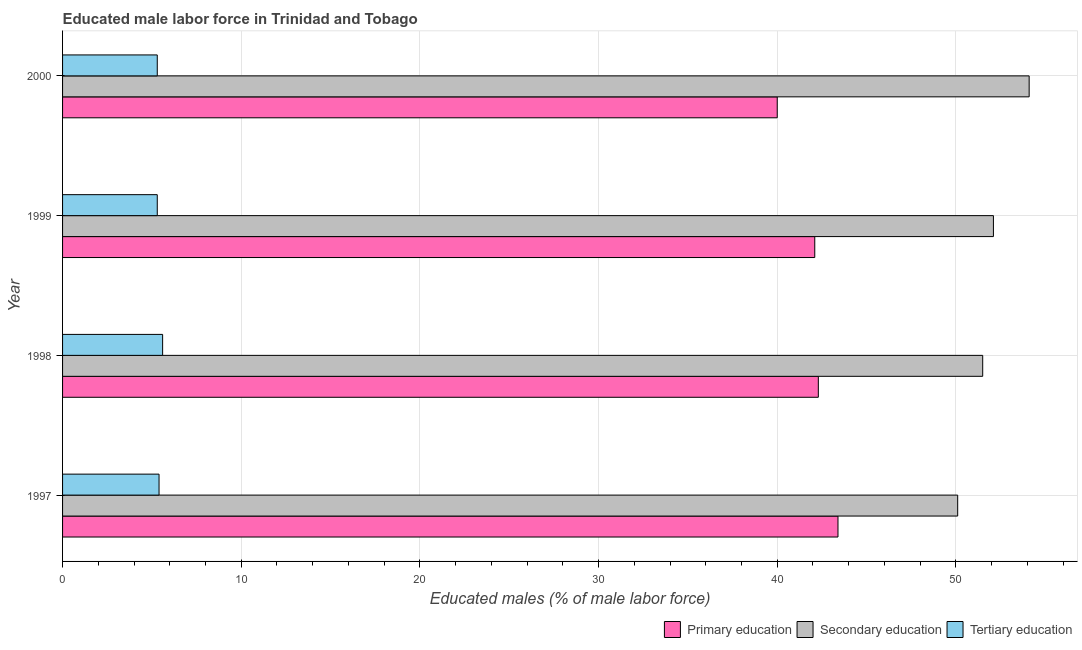How many groups of bars are there?
Offer a terse response. 4. How many bars are there on the 1st tick from the top?
Your response must be concise. 3. In how many cases, is the number of bars for a given year not equal to the number of legend labels?
Give a very brief answer. 0. What is the percentage of male labor force who received tertiary education in 2000?
Provide a succinct answer. 5.3. Across all years, what is the maximum percentage of male labor force who received secondary education?
Offer a very short reply. 54.1. Across all years, what is the minimum percentage of male labor force who received tertiary education?
Offer a terse response. 5.3. In which year was the percentage of male labor force who received primary education minimum?
Provide a succinct answer. 2000. What is the total percentage of male labor force who received secondary education in the graph?
Provide a short and direct response. 207.8. What is the difference between the percentage of male labor force who received primary education in 1999 and that in 2000?
Your response must be concise. 2.1. What is the difference between the percentage of male labor force who received tertiary education in 1997 and the percentage of male labor force who received secondary education in 1998?
Keep it short and to the point. -46.1. What is the average percentage of male labor force who received secondary education per year?
Offer a very short reply. 51.95. In the year 2000, what is the difference between the percentage of male labor force who received primary education and percentage of male labor force who received tertiary education?
Give a very brief answer. 34.7. In how many years, is the percentage of male labor force who received tertiary education greater than 38 %?
Provide a short and direct response. 0. What is the ratio of the percentage of male labor force who received primary education in 1998 to that in 2000?
Give a very brief answer. 1.06. Is the difference between the percentage of male labor force who received tertiary education in 1997 and 1999 greater than the difference between the percentage of male labor force who received secondary education in 1997 and 1999?
Make the answer very short. Yes. Is the sum of the percentage of male labor force who received tertiary education in 1998 and 1999 greater than the maximum percentage of male labor force who received primary education across all years?
Your answer should be compact. No. Is it the case that in every year, the sum of the percentage of male labor force who received primary education and percentage of male labor force who received secondary education is greater than the percentage of male labor force who received tertiary education?
Provide a short and direct response. Yes. How many bars are there?
Ensure brevity in your answer.  12. Are all the bars in the graph horizontal?
Your response must be concise. Yes. Are the values on the major ticks of X-axis written in scientific E-notation?
Make the answer very short. No. Does the graph contain any zero values?
Your answer should be very brief. No. Does the graph contain grids?
Your response must be concise. Yes. Where does the legend appear in the graph?
Your answer should be very brief. Bottom right. How are the legend labels stacked?
Provide a succinct answer. Horizontal. What is the title of the graph?
Give a very brief answer. Educated male labor force in Trinidad and Tobago. Does "Labor Market" appear as one of the legend labels in the graph?
Keep it short and to the point. No. What is the label or title of the X-axis?
Offer a terse response. Educated males (% of male labor force). What is the label or title of the Y-axis?
Give a very brief answer. Year. What is the Educated males (% of male labor force) of Primary education in 1997?
Your answer should be compact. 43.4. What is the Educated males (% of male labor force) in Secondary education in 1997?
Provide a succinct answer. 50.1. What is the Educated males (% of male labor force) in Tertiary education in 1997?
Your response must be concise. 5.4. What is the Educated males (% of male labor force) of Primary education in 1998?
Provide a succinct answer. 42.3. What is the Educated males (% of male labor force) of Secondary education in 1998?
Give a very brief answer. 51.5. What is the Educated males (% of male labor force) of Tertiary education in 1998?
Offer a very short reply. 5.6. What is the Educated males (% of male labor force) in Primary education in 1999?
Make the answer very short. 42.1. What is the Educated males (% of male labor force) of Secondary education in 1999?
Your answer should be very brief. 52.1. What is the Educated males (% of male labor force) in Tertiary education in 1999?
Give a very brief answer. 5.3. What is the Educated males (% of male labor force) in Primary education in 2000?
Provide a succinct answer. 40. What is the Educated males (% of male labor force) of Secondary education in 2000?
Offer a terse response. 54.1. What is the Educated males (% of male labor force) of Tertiary education in 2000?
Keep it short and to the point. 5.3. Across all years, what is the maximum Educated males (% of male labor force) of Primary education?
Keep it short and to the point. 43.4. Across all years, what is the maximum Educated males (% of male labor force) in Secondary education?
Provide a short and direct response. 54.1. Across all years, what is the maximum Educated males (% of male labor force) of Tertiary education?
Keep it short and to the point. 5.6. Across all years, what is the minimum Educated males (% of male labor force) in Secondary education?
Your answer should be very brief. 50.1. Across all years, what is the minimum Educated males (% of male labor force) of Tertiary education?
Your answer should be very brief. 5.3. What is the total Educated males (% of male labor force) in Primary education in the graph?
Your answer should be compact. 167.8. What is the total Educated males (% of male labor force) of Secondary education in the graph?
Your answer should be compact. 207.8. What is the total Educated males (% of male labor force) in Tertiary education in the graph?
Offer a very short reply. 21.6. What is the difference between the Educated males (% of male labor force) of Primary education in 1997 and that in 1998?
Give a very brief answer. 1.1. What is the difference between the Educated males (% of male labor force) of Tertiary education in 1997 and that in 1998?
Give a very brief answer. -0.2. What is the difference between the Educated males (% of male labor force) of Secondary education in 1997 and that in 1999?
Keep it short and to the point. -2. What is the difference between the Educated males (% of male labor force) of Tertiary education in 1997 and that in 1999?
Keep it short and to the point. 0.1. What is the difference between the Educated males (% of male labor force) in Secondary education in 1997 and that in 2000?
Keep it short and to the point. -4. What is the difference between the Educated males (% of male labor force) in Tertiary education in 1997 and that in 2000?
Keep it short and to the point. 0.1. What is the difference between the Educated males (% of male labor force) of Tertiary education in 1998 and that in 1999?
Your answer should be compact. 0.3. What is the difference between the Educated males (% of male labor force) of Tertiary education in 1998 and that in 2000?
Give a very brief answer. 0.3. What is the difference between the Educated males (% of male labor force) in Primary education in 1999 and that in 2000?
Make the answer very short. 2.1. What is the difference between the Educated males (% of male labor force) in Primary education in 1997 and the Educated males (% of male labor force) in Secondary education in 1998?
Offer a terse response. -8.1. What is the difference between the Educated males (% of male labor force) in Primary education in 1997 and the Educated males (% of male labor force) in Tertiary education in 1998?
Your answer should be compact. 37.8. What is the difference between the Educated males (% of male labor force) in Secondary education in 1997 and the Educated males (% of male labor force) in Tertiary education in 1998?
Ensure brevity in your answer.  44.5. What is the difference between the Educated males (% of male labor force) of Primary education in 1997 and the Educated males (% of male labor force) of Tertiary education in 1999?
Provide a succinct answer. 38.1. What is the difference between the Educated males (% of male labor force) in Secondary education in 1997 and the Educated males (% of male labor force) in Tertiary education in 1999?
Provide a succinct answer. 44.8. What is the difference between the Educated males (% of male labor force) in Primary education in 1997 and the Educated males (% of male labor force) in Tertiary education in 2000?
Make the answer very short. 38.1. What is the difference between the Educated males (% of male labor force) of Secondary education in 1997 and the Educated males (% of male labor force) of Tertiary education in 2000?
Give a very brief answer. 44.8. What is the difference between the Educated males (% of male labor force) in Secondary education in 1998 and the Educated males (% of male labor force) in Tertiary education in 1999?
Give a very brief answer. 46.2. What is the difference between the Educated males (% of male labor force) in Primary education in 1998 and the Educated males (% of male labor force) in Secondary education in 2000?
Ensure brevity in your answer.  -11.8. What is the difference between the Educated males (% of male labor force) in Primary education in 1998 and the Educated males (% of male labor force) in Tertiary education in 2000?
Your answer should be compact. 37. What is the difference between the Educated males (% of male labor force) in Secondary education in 1998 and the Educated males (% of male labor force) in Tertiary education in 2000?
Provide a short and direct response. 46.2. What is the difference between the Educated males (% of male labor force) of Primary education in 1999 and the Educated males (% of male labor force) of Tertiary education in 2000?
Provide a short and direct response. 36.8. What is the difference between the Educated males (% of male labor force) in Secondary education in 1999 and the Educated males (% of male labor force) in Tertiary education in 2000?
Ensure brevity in your answer.  46.8. What is the average Educated males (% of male labor force) of Primary education per year?
Make the answer very short. 41.95. What is the average Educated males (% of male labor force) of Secondary education per year?
Provide a succinct answer. 51.95. What is the average Educated males (% of male labor force) in Tertiary education per year?
Ensure brevity in your answer.  5.4. In the year 1997, what is the difference between the Educated males (% of male labor force) of Primary education and Educated males (% of male labor force) of Secondary education?
Offer a terse response. -6.7. In the year 1997, what is the difference between the Educated males (% of male labor force) of Secondary education and Educated males (% of male labor force) of Tertiary education?
Provide a short and direct response. 44.7. In the year 1998, what is the difference between the Educated males (% of male labor force) in Primary education and Educated males (% of male labor force) in Secondary education?
Make the answer very short. -9.2. In the year 1998, what is the difference between the Educated males (% of male labor force) of Primary education and Educated males (% of male labor force) of Tertiary education?
Your answer should be compact. 36.7. In the year 1998, what is the difference between the Educated males (% of male labor force) in Secondary education and Educated males (% of male labor force) in Tertiary education?
Offer a very short reply. 45.9. In the year 1999, what is the difference between the Educated males (% of male labor force) of Primary education and Educated males (% of male labor force) of Secondary education?
Make the answer very short. -10. In the year 1999, what is the difference between the Educated males (% of male labor force) of Primary education and Educated males (% of male labor force) of Tertiary education?
Provide a succinct answer. 36.8. In the year 1999, what is the difference between the Educated males (% of male labor force) in Secondary education and Educated males (% of male labor force) in Tertiary education?
Give a very brief answer. 46.8. In the year 2000, what is the difference between the Educated males (% of male labor force) in Primary education and Educated males (% of male labor force) in Secondary education?
Offer a very short reply. -14.1. In the year 2000, what is the difference between the Educated males (% of male labor force) in Primary education and Educated males (% of male labor force) in Tertiary education?
Offer a very short reply. 34.7. In the year 2000, what is the difference between the Educated males (% of male labor force) in Secondary education and Educated males (% of male labor force) in Tertiary education?
Your answer should be very brief. 48.8. What is the ratio of the Educated males (% of male labor force) in Primary education in 1997 to that in 1998?
Your answer should be very brief. 1.03. What is the ratio of the Educated males (% of male labor force) in Secondary education in 1997 to that in 1998?
Offer a very short reply. 0.97. What is the ratio of the Educated males (% of male labor force) of Tertiary education in 1997 to that in 1998?
Offer a very short reply. 0.96. What is the ratio of the Educated males (% of male labor force) in Primary education in 1997 to that in 1999?
Your answer should be compact. 1.03. What is the ratio of the Educated males (% of male labor force) in Secondary education in 1997 to that in 1999?
Your answer should be very brief. 0.96. What is the ratio of the Educated males (% of male labor force) in Tertiary education in 1997 to that in 1999?
Your answer should be compact. 1.02. What is the ratio of the Educated males (% of male labor force) in Primary education in 1997 to that in 2000?
Ensure brevity in your answer.  1.08. What is the ratio of the Educated males (% of male labor force) of Secondary education in 1997 to that in 2000?
Your response must be concise. 0.93. What is the ratio of the Educated males (% of male labor force) in Tertiary education in 1997 to that in 2000?
Offer a terse response. 1.02. What is the ratio of the Educated males (% of male labor force) of Primary education in 1998 to that in 1999?
Ensure brevity in your answer.  1. What is the ratio of the Educated males (% of male labor force) of Tertiary education in 1998 to that in 1999?
Give a very brief answer. 1.06. What is the ratio of the Educated males (% of male labor force) of Primary education in 1998 to that in 2000?
Ensure brevity in your answer.  1.06. What is the ratio of the Educated males (% of male labor force) in Secondary education in 1998 to that in 2000?
Offer a terse response. 0.95. What is the ratio of the Educated males (% of male labor force) in Tertiary education in 1998 to that in 2000?
Your answer should be compact. 1.06. What is the ratio of the Educated males (% of male labor force) of Primary education in 1999 to that in 2000?
Your answer should be very brief. 1.05. What is the difference between the highest and the lowest Educated males (% of male labor force) of Primary education?
Make the answer very short. 3.4. What is the difference between the highest and the lowest Educated males (% of male labor force) in Tertiary education?
Your answer should be compact. 0.3. 